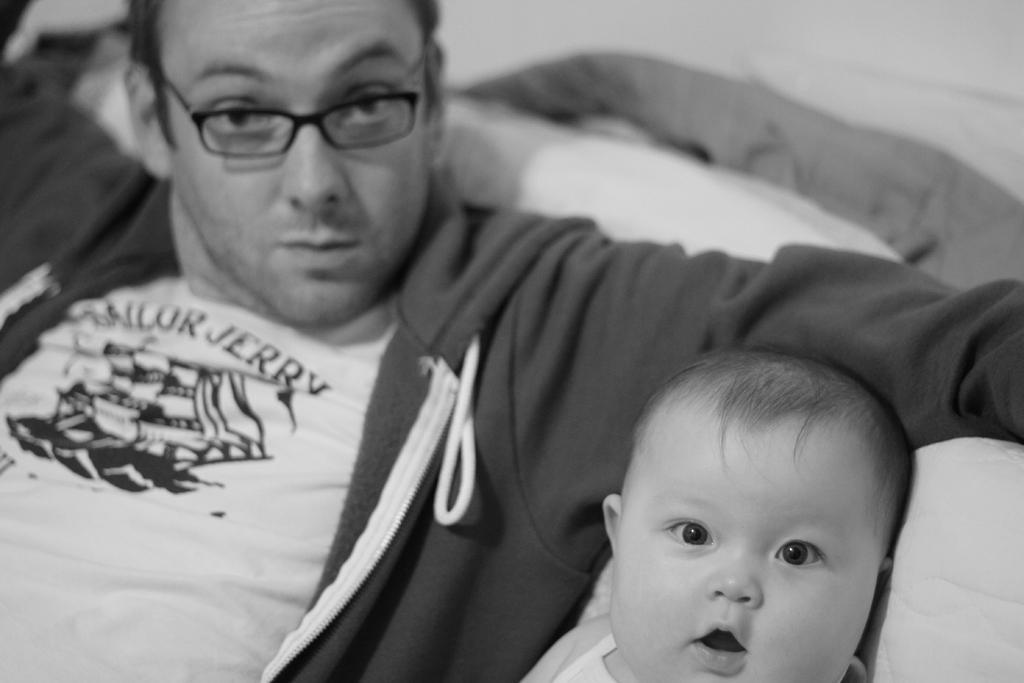Describe this image in one or two sentences. In this image there is a child towards the bottom of the image, there is a man, he is wearing spectacles, there is an object behind the man that looks like a pillow, there is an object behind the child that looks like a pillow, there is an object towards the top of the image. 